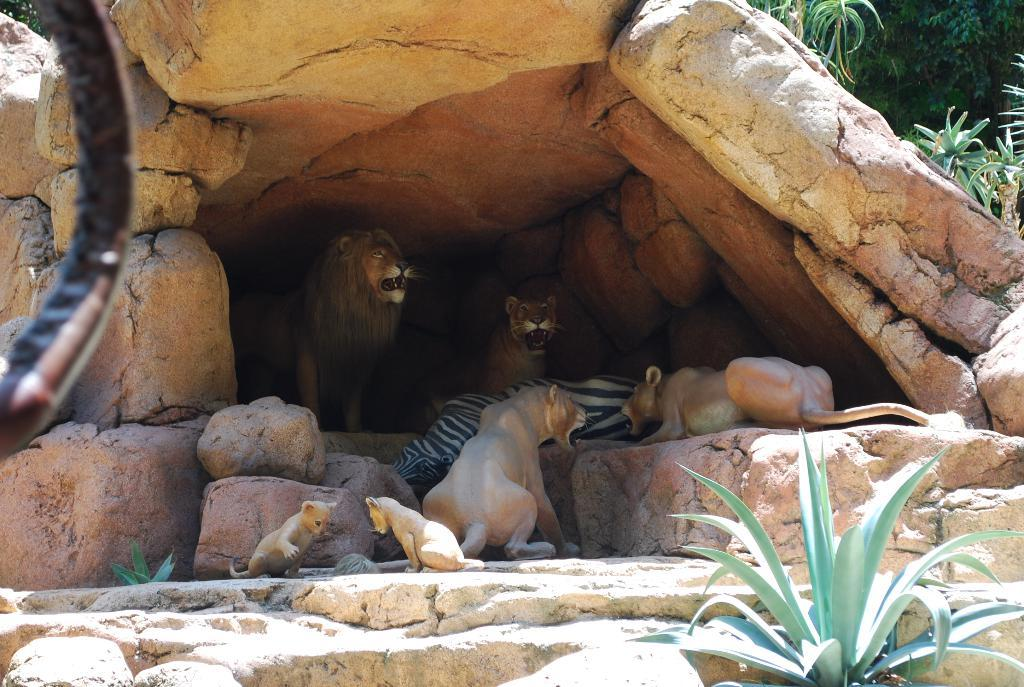What is the main feature of the image? There is a cave in the image. What can be found inside the cave? There are sculptures of lions and a sculpture of a zebra in the cave. What can be seen in the background of the image? There are trees and plants in the background of the image. Can you see any snails crawling on the sculptures in the image? There is no mention of snails in the image, so we cannot determine if they are present or not. Is this image taken in a park or at the coast? The image does not provide any information about the location being a park or the coast, so we cannot determine that. 